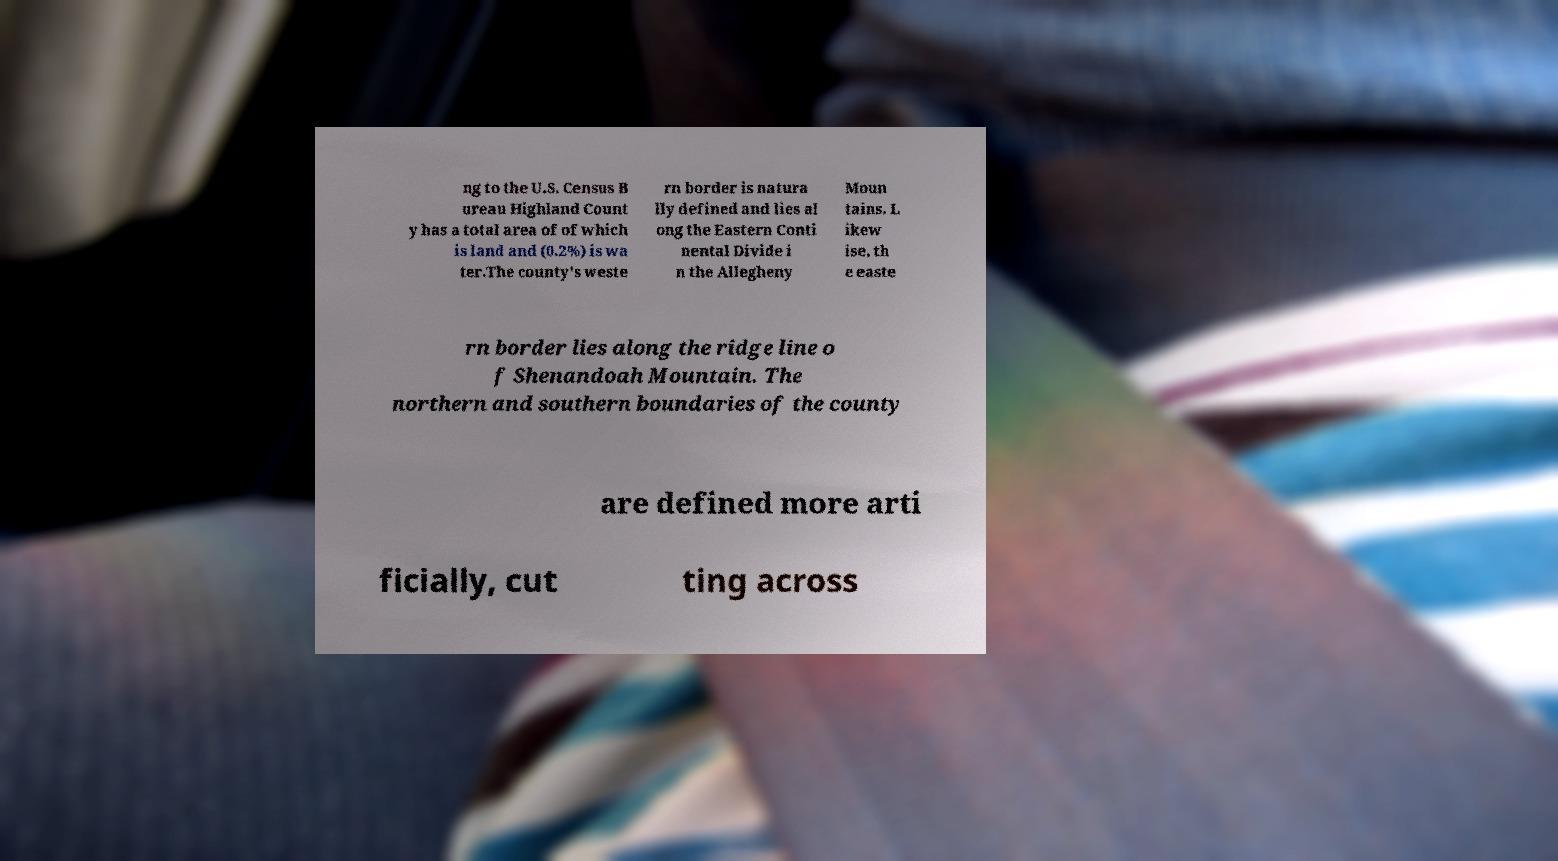Please identify and transcribe the text found in this image. ng to the U.S. Census B ureau Highland Count y has a total area of of which is land and (0.2%) is wa ter.The county's weste rn border is natura lly defined and lies al ong the Eastern Conti nental Divide i n the Allegheny Moun tains. L ikew ise, th e easte rn border lies along the ridge line o f Shenandoah Mountain. The northern and southern boundaries of the county are defined more arti ficially, cut ting across 